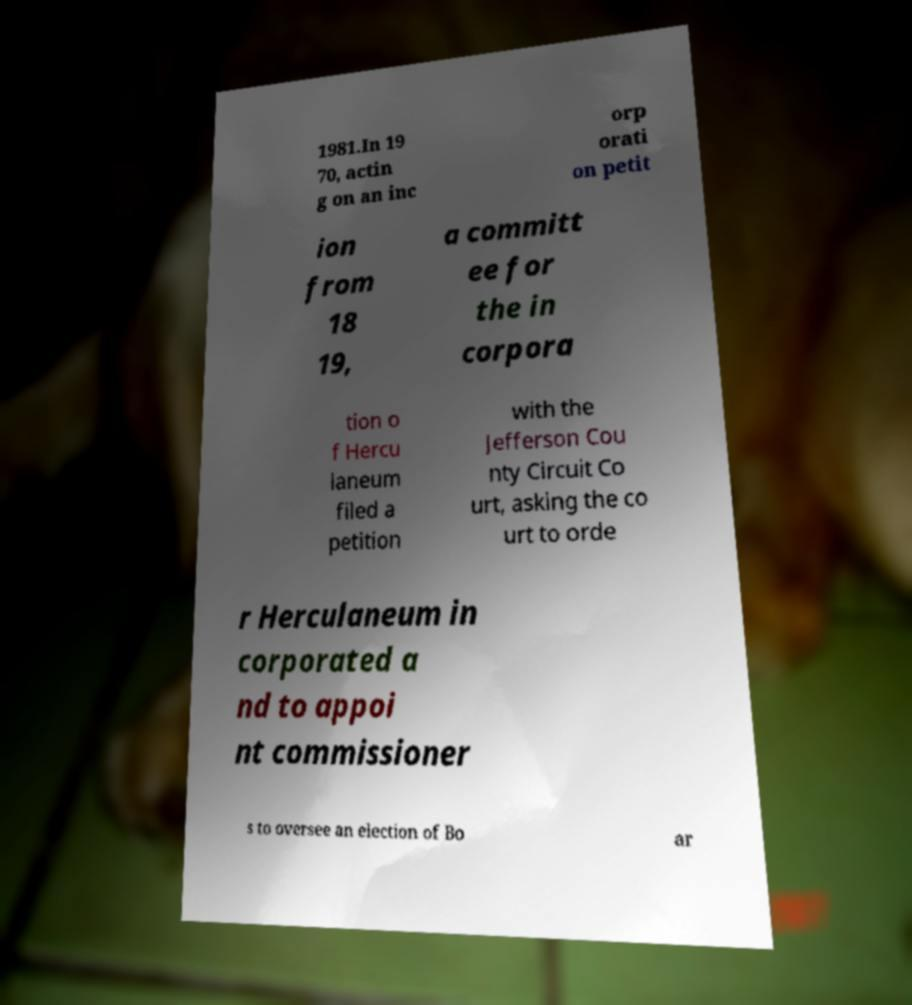Please identify and transcribe the text found in this image. 1981.In 19 70, actin g on an inc orp orati on petit ion from 18 19, a committ ee for the in corpora tion o f Hercu laneum filed a petition with the Jefferson Cou nty Circuit Co urt, asking the co urt to orde r Herculaneum in corporated a nd to appoi nt commissioner s to oversee an election of Bo ar 